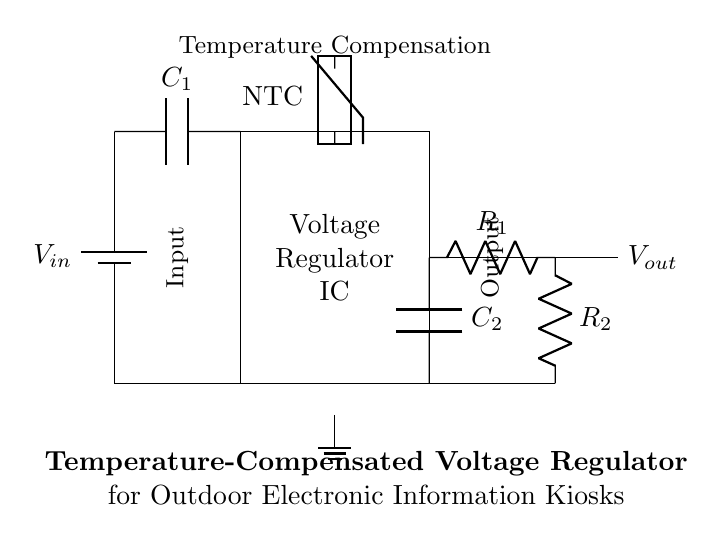What is the input component in this circuit? The input component is the battery, labeled as V in, which provides the voltage supply to the circuit.
Answer: battery What is the purpose of the thermistor in this circuit? The thermistor is used for temperature compensation, which helps to adjust the output voltage in response to temperature changes.
Answer: temperature compensation What type of capacitors are used in this circuit? The circuit contains two capacitors, labeled C1 and C2, which are utilized for input and output stabilization.
Answer: input and output What values are represented by R1 and R2 in the feedback system? R1 and R2 are resistors that set the feedback ratio for the voltage regulator, controlling the output voltage level based on the input voltage.
Answer: feedback ratio How does the circuit ensure a stable output voltage? The voltage regulator IC regulates the output voltage while the thermistor provides temperature compensation, ensuring stable performance across varying conditions.
Answer: voltage regulation What is the significance of the ground connection in this circuit? The ground connection serves as a reference point for the circuit, completing the circuit path and ensuring that all components function properly with a common return.
Answer: reference point 